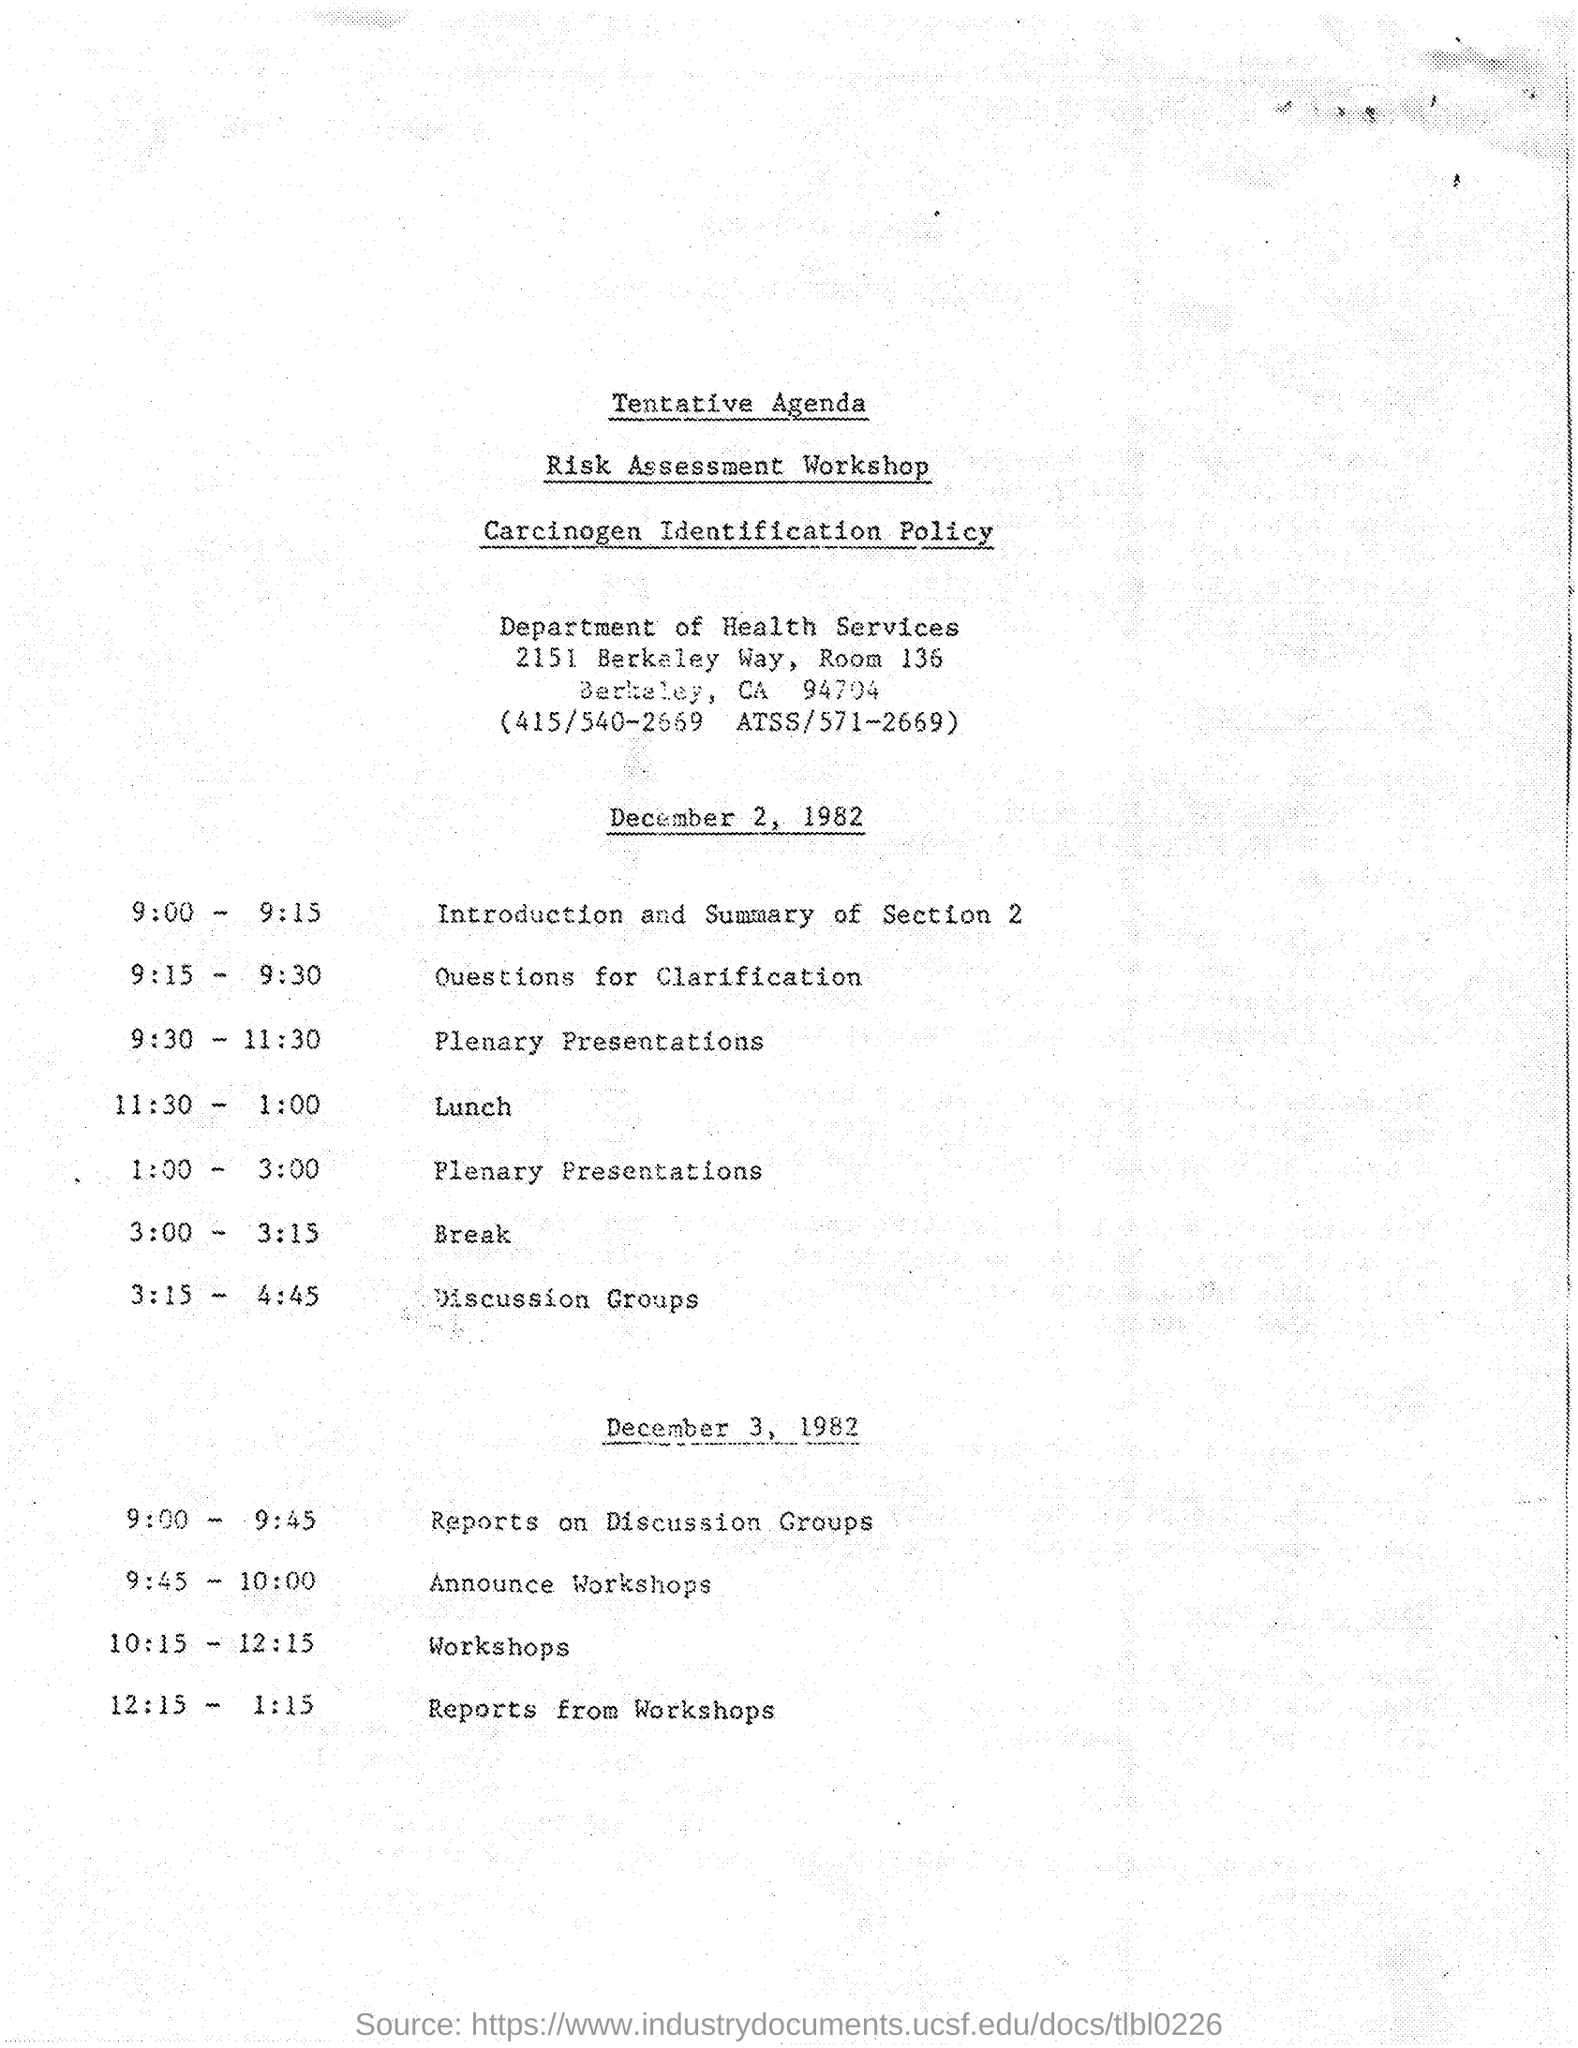Specify some key components in this picture. The programme scheduled from 9:15 to 9:30 is 'Which programme?' The workshop is related to the Health Services department. 